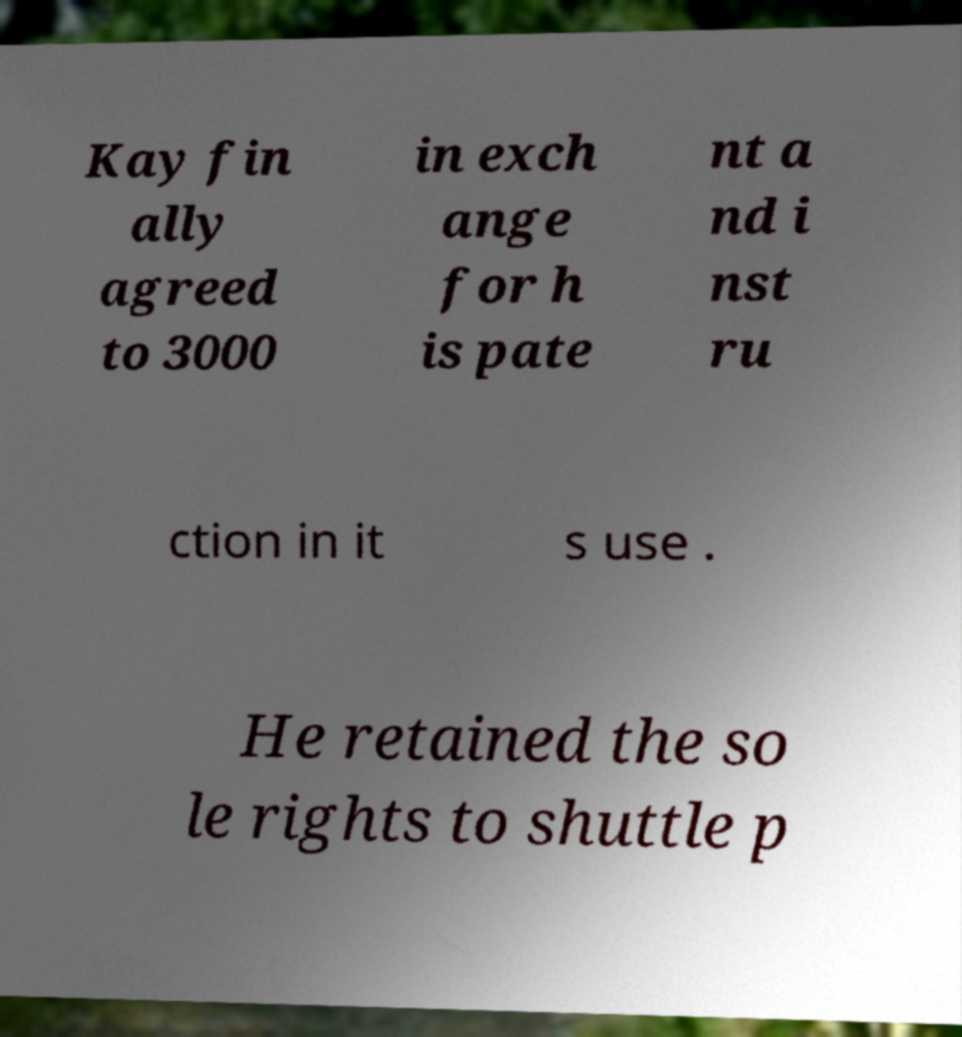Could you assist in decoding the text presented in this image and type it out clearly? Kay fin ally agreed to 3000 in exch ange for h is pate nt a nd i nst ru ction in it s use . He retained the so le rights to shuttle p 